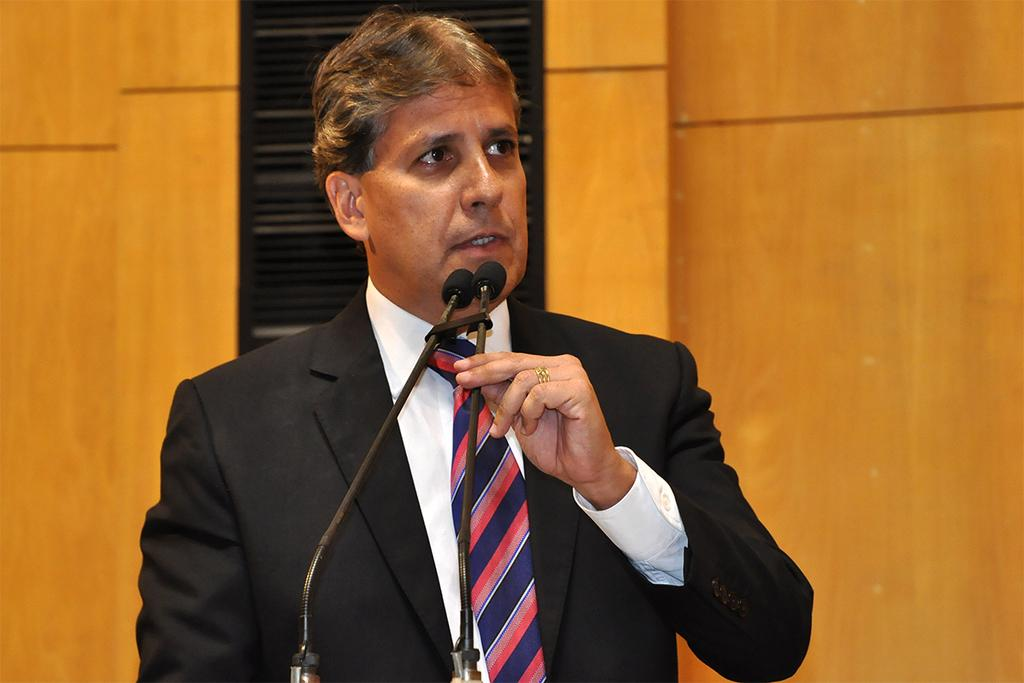Who is the main subject in the image? There is a man in the image. What is the man wearing? The man is wearing a blazer and a tie. What is the man holding in his hand? The man is holding a mic in his hand. What is the man doing in the image? The man is talking. What can be seen in the background of the image? There is a wall in the background of the image. What type of stocking is the governor wearing in the image? There is no governor or stocking present in the image. How many cents are visible in the image? There are no cents visible in the image. 